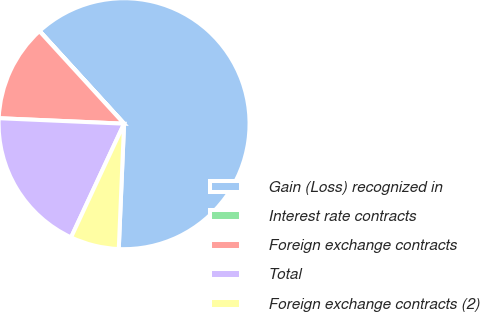<chart> <loc_0><loc_0><loc_500><loc_500><pie_chart><fcel>Gain (Loss) recognized in<fcel>Interest rate contracts<fcel>Foreign exchange contracts<fcel>Total<fcel>Foreign exchange contracts (2)<nl><fcel>62.43%<fcel>0.03%<fcel>12.51%<fcel>18.75%<fcel>6.27%<nl></chart> 